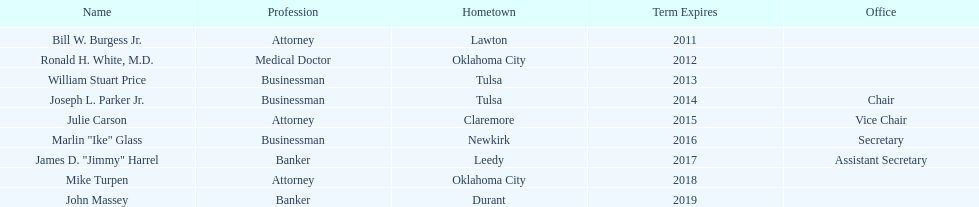How many of the current state regents will be in office until at least 2016? 4. 